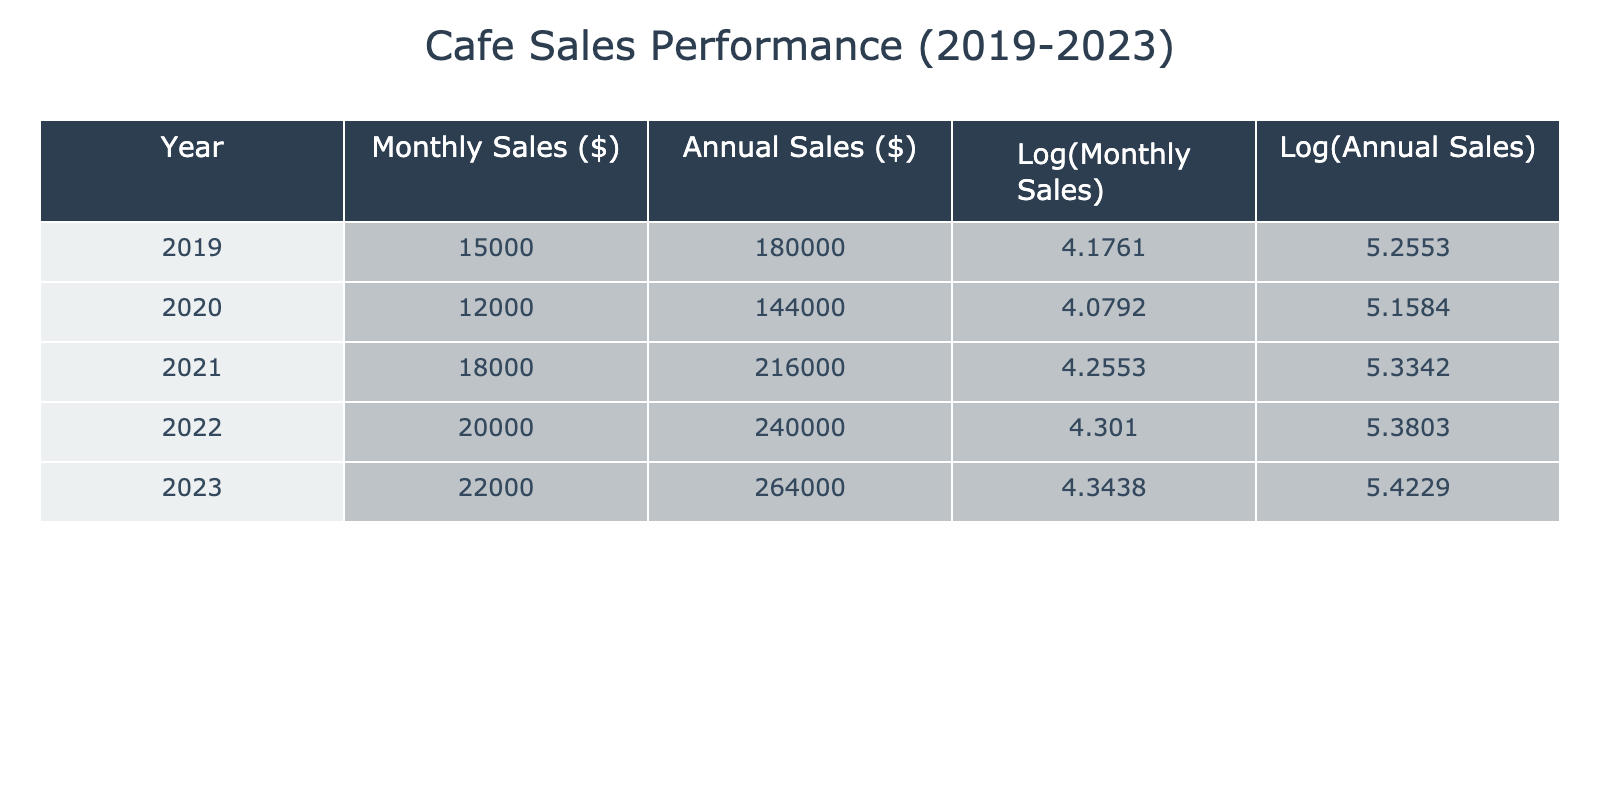What was the annual sales figure for 2022? To find the annual sales for 2022, you look at the row corresponding to the year 2022 in the table. The value listed under "Annual Sales ($)" for that year is 240000.
Answer: 240000 What is the difference in monthly sales between 2021 and 2020? First, locate the monthly sales for both years in the table: for 2021 it is 18000 and for 2020 it is 12000. The difference is calculated as 18000 - 12000 = 6000.
Answer: 6000 Is the log of monthly sales for 2023 greater than that for 2021? Check the log values for both years: for 2023 it is 4.3438 and for 2021 it is 4.2553. Since 4.3438 is greater than 4.2553, the statement is true.
Answer: Yes What was the average monthly sales over the five years? To find the average, sum the monthly sales figures for each year: 15000 + 12000 + 18000 + 20000 + 22000 = 107000. Then divide by the number of years, which is 5: 107000 / 5 = 21400.
Answer: 21400 What year had the highest annual sales, and what was that value? Review the "Annual Sales ($)" column to find the highest value. Looking down the list, the year 2023 has the highest annual sales of 264000.
Answer: 2023, 264000 Was there a decrease in monthly sales from 2019 to 2020? Check the monthly sales figures: for 2019 it is 15000 and for 2020 it is 12000. Since 12000 is less than 15000, there was a decrease.
Answer: Yes Calculate the percentage increase in annual sales from 2020 to 2023. Find the annual sales for those years: 2020 is 144000 and 2023 is 264000. The increase is 264000 - 144000 = 120000. To find the percentage increase, use the formula (increase/original) * 100, which gives (120000/144000) * 100 = 83.33%.
Answer: 83.33% Which year experienced the highest monthly sales and what was the amount? Check the "Monthly Sales ($)" column, and the highest value is for 2023, which is 22000.
Answer: 2023, 22000 What is true about the logarithm of annual sales for 2022 compared to that for 2019? Looking at the "Log(Annual Sales)" values, for 2022 it is 5.3803 and for 2019 it is 5.2553. Since 5.3803 is greater than 5.2553, the statement is true.
Answer: Yes 